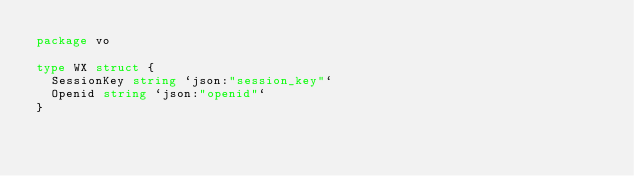<code> <loc_0><loc_0><loc_500><loc_500><_Go_>package vo

type WX struct {
	SessionKey string `json:"session_key"`
	Openid string `json:"openid"`
} 
</code> 